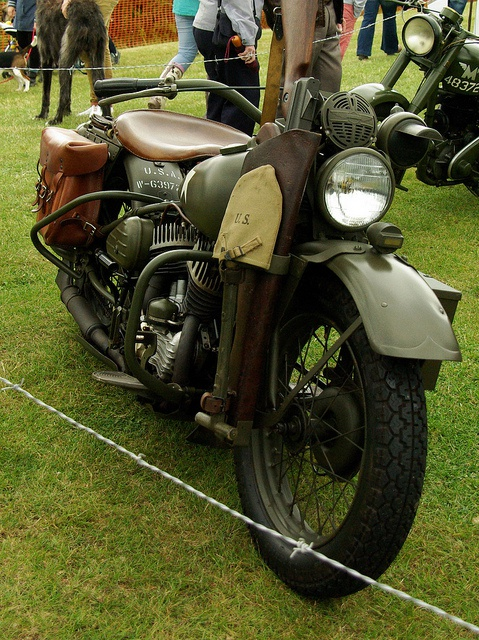Describe the objects in this image and their specific colors. I can see motorcycle in darkgreen, black, olive, and gray tones, handbag in darkgreen, black, maroon, brown, and ivory tones, people in darkgreen, black, darkgray, gray, and lightgray tones, people in darkgreen, black, and gray tones, and motorcycle in darkgreen, black, gray, and olive tones in this image. 